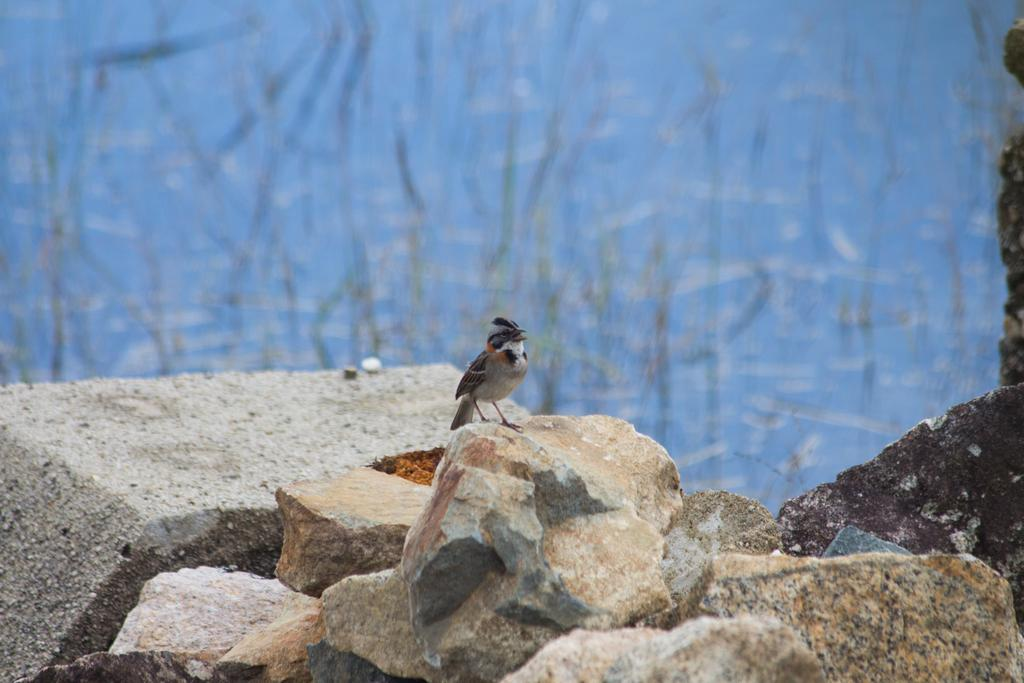What is the main subject of the image? There is a bird on a stone in the image. What can be seen in the foreground of the image? There are rocks in the foreground of the image. What type of vegetation is visible in the background of the image? There are plants visible in the background of the image. What is the water element in the image? There is water present in the image. How many pizzas are being smashed by the bird in the image? There are no pizzas present in the image, and the bird is not smashing anything. 